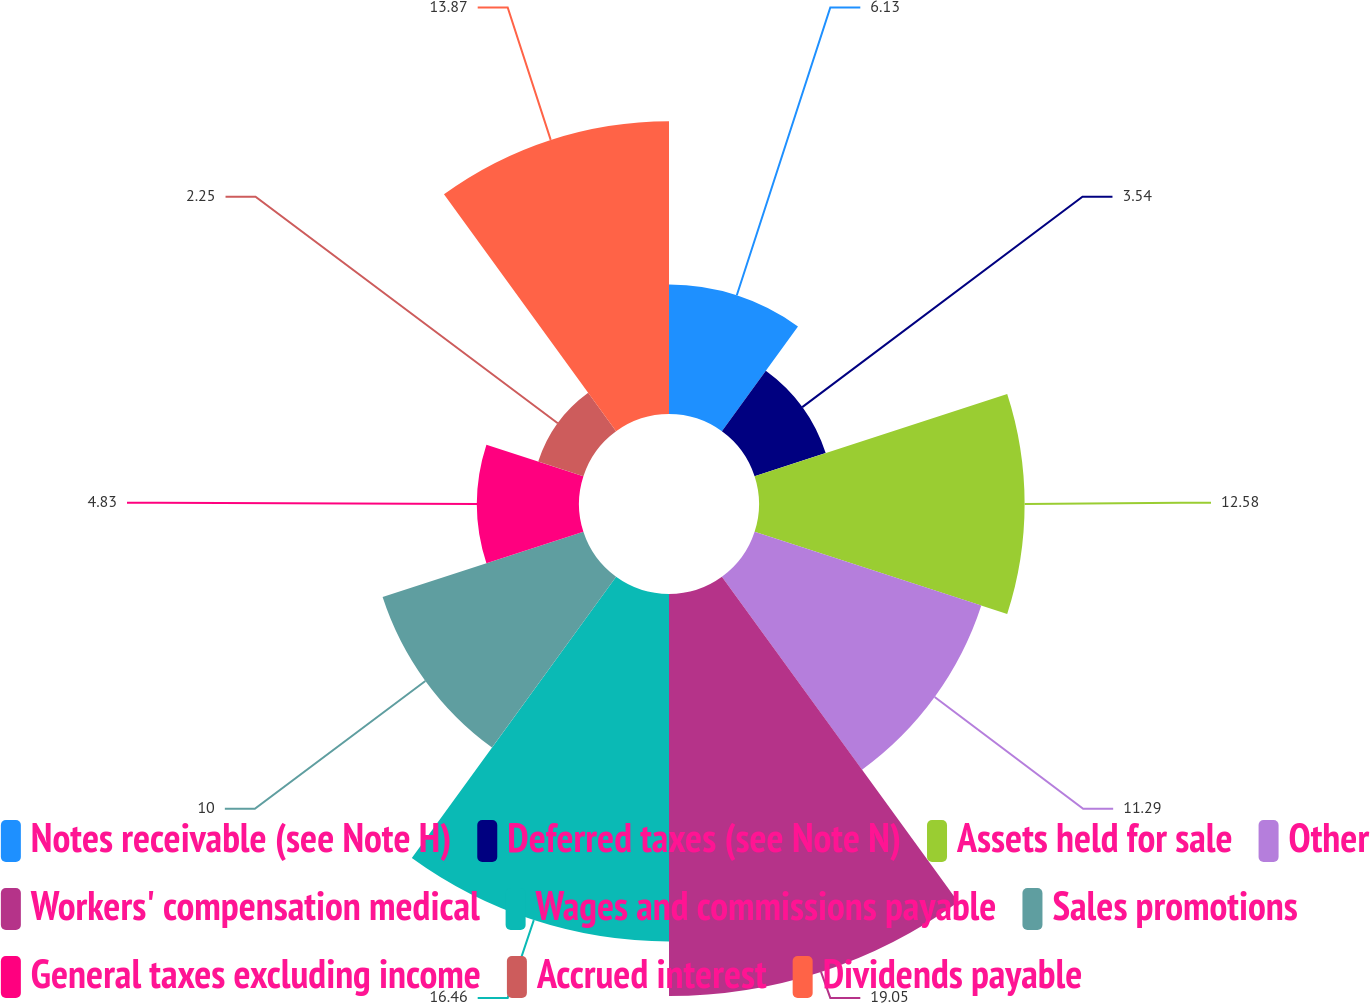<chart> <loc_0><loc_0><loc_500><loc_500><pie_chart><fcel>Notes receivable (see Note H)<fcel>Deferred taxes (see Note N)<fcel>Assets held for sale<fcel>Other<fcel>Workers' compensation medical<fcel>Wages and commissions payable<fcel>Sales promotions<fcel>General taxes excluding income<fcel>Accrued interest<fcel>Dividends payable<nl><fcel>6.13%<fcel>3.54%<fcel>12.58%<fcel>11.29%<fcel>19.04%<fcel>16.46%<fcel>10.0%<fcel>4.83%<fcel>2.25%<fcel>13.87%<nl></chart> 